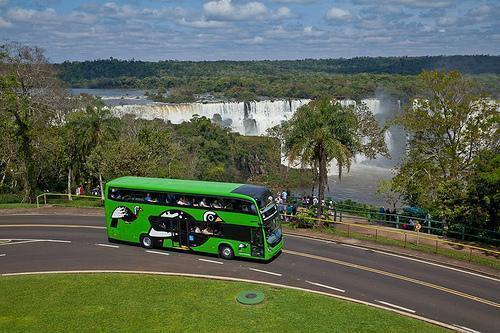How many lanes of traffic are pictured?
Give a very brief answer. 3. How many levels are on the bus?
Give a very brief answer. 2. 